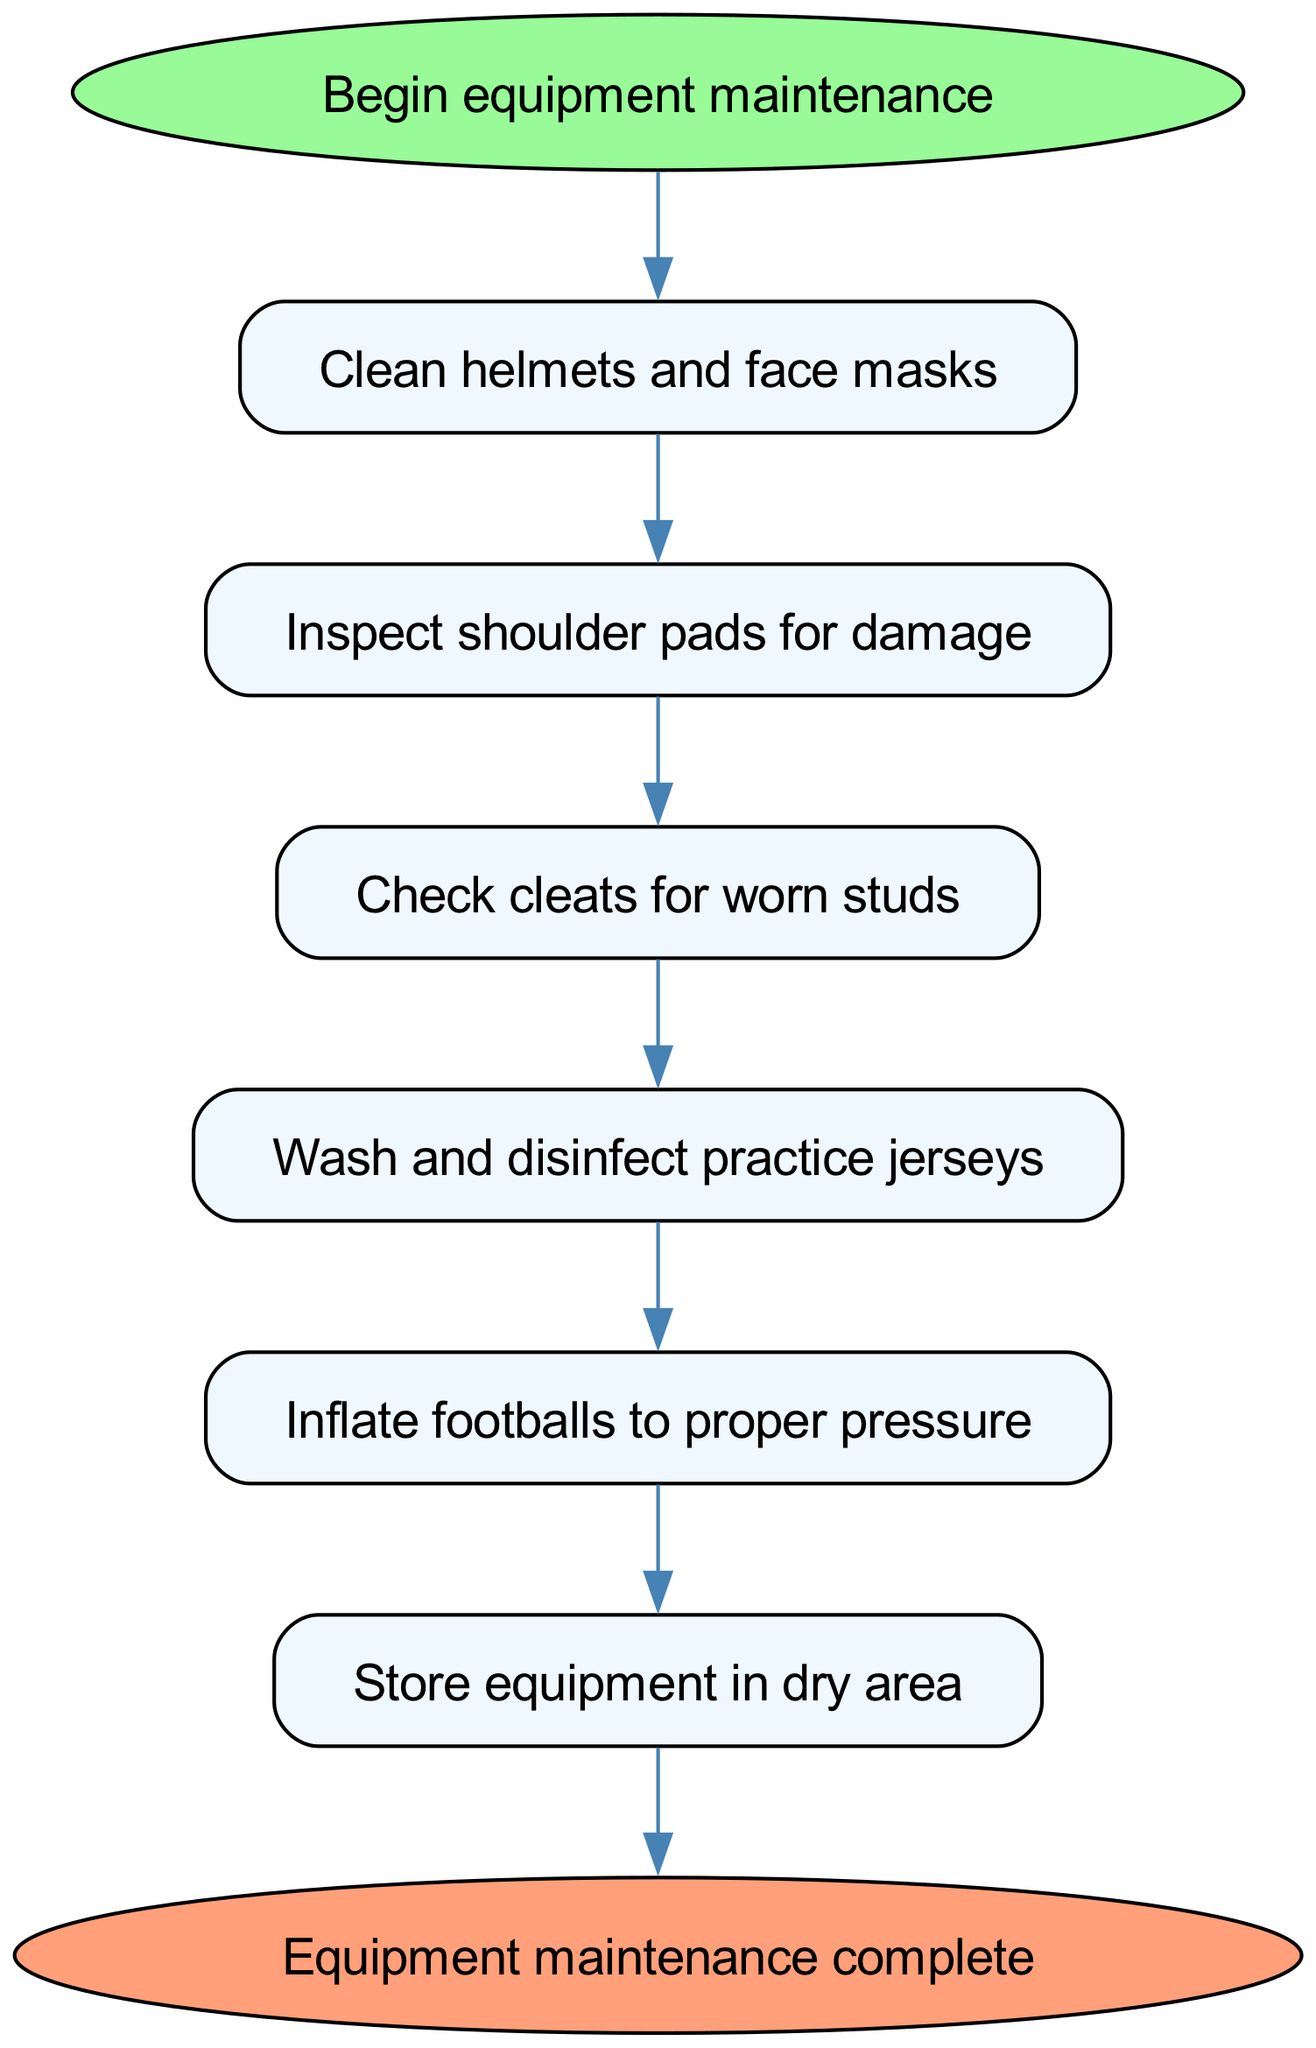What is the first step in the maintenance process? The first step is identified in the diagram as the beginning of the maintenance process leading to "Clean helmets and face masks."
Answer: Clean helmets and face masks How many steps are there in the diagram? By counting each of the steps listed in the flow chart, you can see there are six distinct steps before reaching completion.
Answer: 6 What action follows inspecting shoulder pads? Following the action of "Inspect shoulder pads for damage," the next step documented is "Check cleats for worn studs."
Answer: Check cleats for worn studs What is the last step indicated in the maintenance process? The last step in the flow chart, leading to the end of the process, is to "Store equipment in dry area."
Answer: Store equipment in dry area What must you do before storing football equipment? Before reaching the end of the equipment maintenance process, you must "Inflate footballs to proper pressure" right before storage.
Answer: Inflate footballs to proper pressure Which step requires washing and disinfecting? The step that requires washing and disinfecting is clearly marked as "Wash and disinfect practice jerseys."
Answer: Wash and disinfect practice jerseys What is the process flow from cleaning helmets to checking cleats? The flow progresses from "Clean helmets and face masks" to "Inspect shoulder pads for damage," and then to "Check cleats for worn studs," showing a sequence of three actions.
Answer: Clean helmets and face masks, Inspect shoulder pads for damage, Check cleats for worn studs 